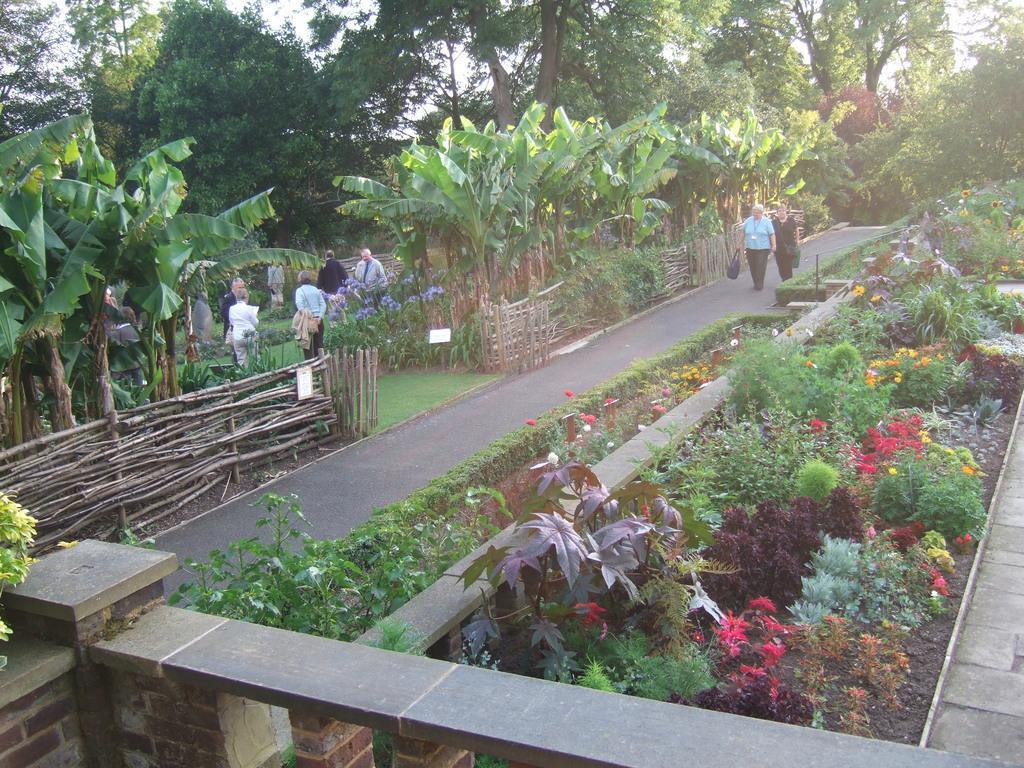Describe this image in one or two sentences. In this image there are two people walking on the road. A person is holding a bag. Few people are standing on the grassland having plants. Right side there are plants having flowers. Bottom of the image there is a wall. Left side there is a fence. Behind there are trees. Background there are trees. Right side there is a path. 